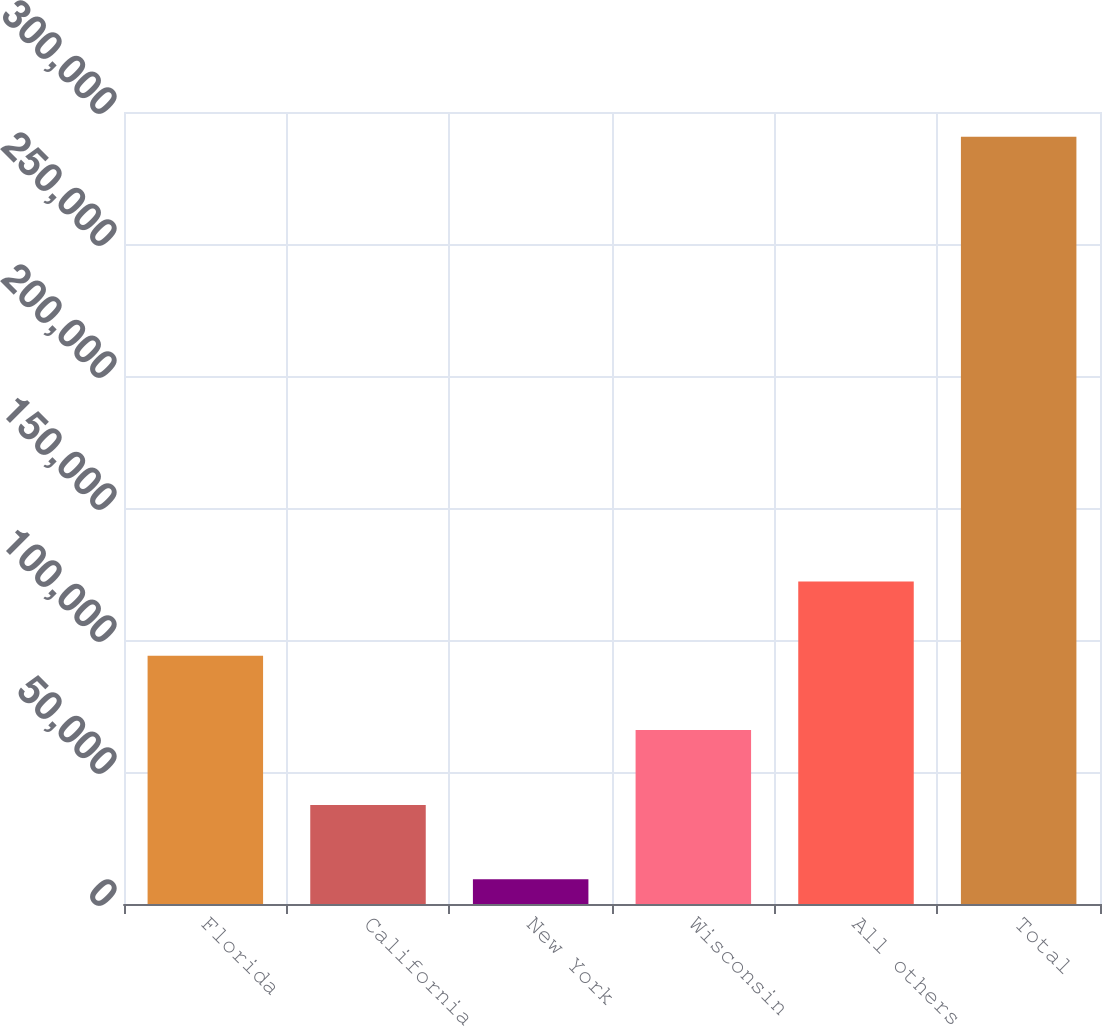Convert chart to OTSL. <chart><loc_0><loc_0><loc_500><loc_500><bar_chart><fcel>Florida<fcel>California<fcel>New York<fcel>Wisconsin<fcel>All others<fcel>Total<nl><fcel>94003.8<fcel>37507.8<fcel>9386<fcel>65882<fcel>122126<fcel>290604<nl></chart> 